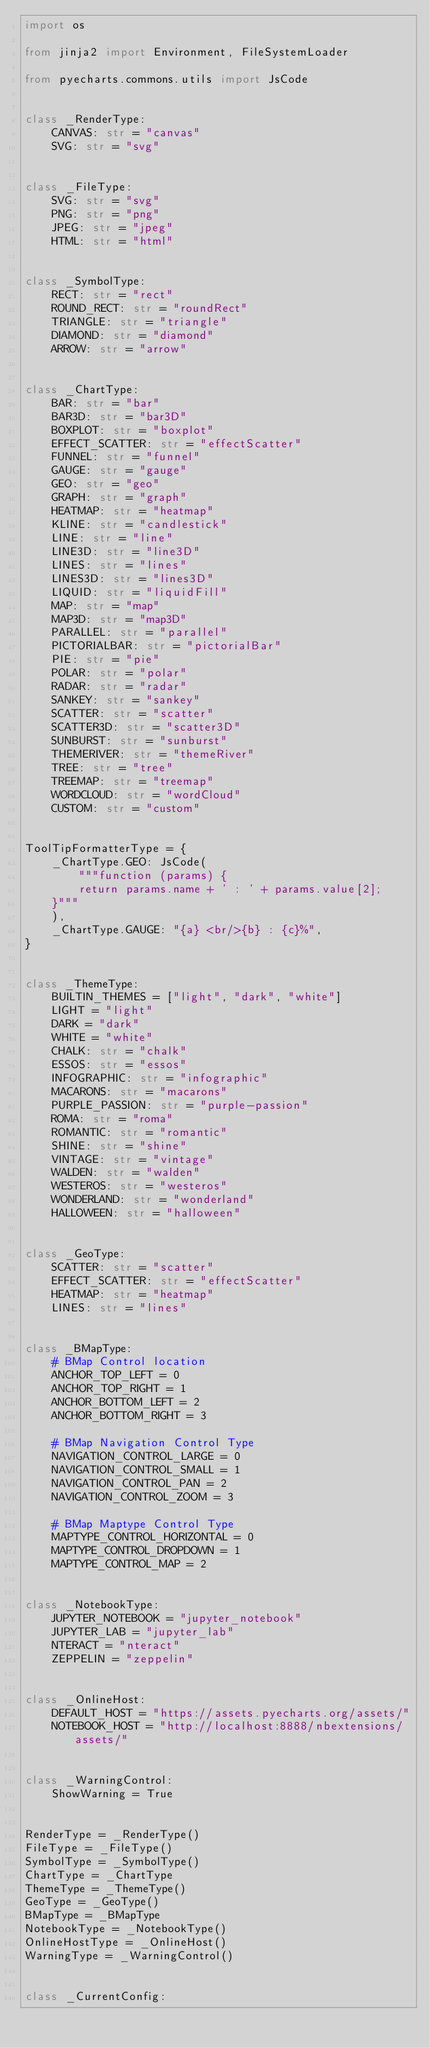Convert code to text. <code><loc_0><loc_0><loc_500><loc_500><_Python_>import os

from jinja2 import Environment, FileSystemLoader

from pyecharts.commons.utils import JsCode


class _RenderType:
    CANVAS: str = "canvas"
    SVG: str = "svg"


class _FileType:
    SVG: str = "svg"
    PNG: str = "png"
    JPEG: str = "jpeg"
    HTML: str = "html"


class _SymbolType:
    RECT: str = "rect"
    ROUND_RECT: str = "roundRect"
    TRIANGLE: str = "triangle"
    DIAMOND: str = "diamond"
    ARROW: str = "arrow"


class _ChartType:
    BAR: str = "bar"
    BAR3D: str = "bar3D"
    BOXPLOT: str = "boxplot"
    EFFECT_SCATTER: str = "effectScatter"
    FUNNEL: str = "funnel"
    GAUGE: str = "gauge"
    GEO: str = "geo"
    GRAPH: str = "graph"
    HEATMAP: str = "heatmap"
    KLINE: str = "candlestick"
    LINE: str = "line"
    LINE3D: str = "line3D"
    LINES: str = "lines"
    LINES3D: str = "lines3D"
    LIQUID: str = "liquidFill"
    MAP: str = "map"
    MAP3D: str = "map3D"
    PARALLEL: str = "parallel"
    PICTORIALBAR: str = "pictorialBar"
    PIE: str = "pie"
    POLAR: str = "polar"
    RADAR: str = "radar"
    SANKEY: str = "sankey"
    SCATTER: str = "scatter"
    SCATTER3D: str = "scatter3D"
    SUNBURST: str = "sunburst"
    THEMERIVER: str = "themeRiver"
    TREE: str = "tree"
    TREEMAP: str = "treemap"
    WORDCLOUD: str = "wordCloud"
    CUSTOM: str = "custom"


ToolTipFormatterType = {
    _ChartType.GEO: JsCode(
        """function (params) {
        return params.name + ' : ' + params.value[2];
    }"""
    ),
    _ChartType.GAUGE: "{a} <br/>{b} : {c}%",
}


class _ThemeType:
    BUILTIN_THEMES = ["light", "dark", "white"]
    LIGHT = "light"
    DARK = "dark"
    WHITE = "white"
    CHALK: str = "chalk"
    ESSOS: str = "essos"
    INFOGRAPHIC: str = "infographic"
    MACARONS: str = "macarons"
    PURPLE_PASSION: str = "purple-passion"
    ROMA: str = "roma"
    ROMANTIC: str = "romantic"
    SHINE: str = "shine"
    VINTAGE: str = "vintage"
    WALDEN: str = "walden"
    WESTEROS: str = "westeros"
    WONDERLAND: str = "wonderland"
    HALLOWEEN: str = "halloween"


class _GeoType:
    SCATTER: str = "scatter"
    EFFECT_SCATTER: str = "effectScatter"
    HEATMAP: str = "heatmap"
    LINES: str = "lines"


class _BMapType:
    # BMap Control location
    ANCHOR_TOP_LEFT = 0
    ANCHOR_TOP_RIGHT = 1
    ANCHOR_BOTTOM_LEFT = 2
    ANCHOR_BOTTOM_RIGHT = 3

    # BMap Navigation Control Type
    NAVIGATION_CONTROL_LARGE = 0
    NAVIGATION_CONTROL_SMALL = 1
    NAVIGATION_CONTROL_PAN = 2
    NAVIGATION_CONTROL_ZOOM = 3

    # BMap Maptype Control Type
    MAPTYPE_CONTROL_HORIZONTAL = 0
    MAPTYPE_CONTROL_DROPDOWN = 1
    MAPTYPE_CONTROL_MAP = 2


class _NotebookType:
    JUPYTER_NOTEBOOK = "jupyter_notebook"
    JUPYTER_LAB = "jupyter_lab"
    NTERACT = "nteract"
    ZEPPELIN = "zeppelin"


class _OnlineHost:
    DEFAULT_HOST = "https://assets.pyecharts.org/assets/"
    NOTEBOOK_HOST = "http://localhost:8888/nbextensions/assets/"


class _WarningControl:
    ShowWarning = True


RenderType = _RenderType()
FileType = _FileType()
SymbolType = _SymbolType()
ChartType = _ChartType
ThemeType = _ThemeType()
GeoType = _GeoType()
BMapType = _BMapType
NotebookType = _NotebookType()
OnlineHostType = _OnlineHost()
WarningType = _WarningControl()


class _CurrentConfig:</code> 